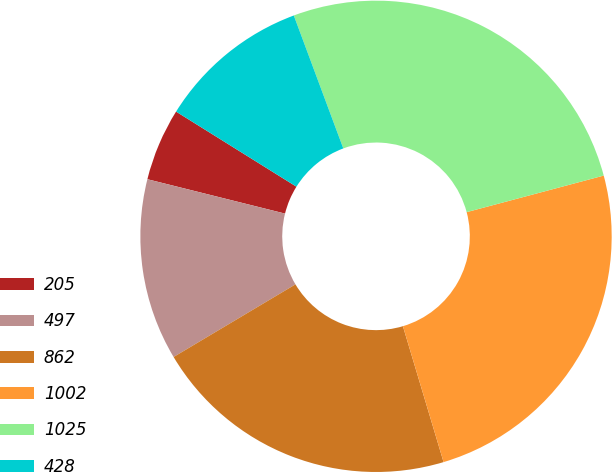<chart> <loc_0><loc_0><loc_500><loc_500><pie_chart><fcel>205<fcel>497<fcel>862<fcel>1002<fcel>1025<fcel>428<nl><fcel>4.98%<fcel>12.45%<fcel>21.07%<fcel>24.52%<fcel>26.52%<fcel>10.45%<nl></chart> 